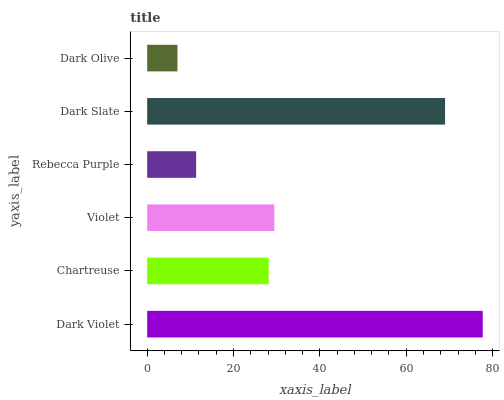Is Dark Olive the minimum?
Answer yes or no. Yes. Is Dark Violet the maximum?
Answer yes or no. Yes. Is Chartreuse the minimum?
Answer yes or no. No. Is Chartreuse the maximum?
Answer yes or no. No. Is Dark Violet greater than Chartreuse?
Answer yes or no. Yes. Is Chartreuse less than Dark Violet?
Answer yes or no. Yes. Is Chartreuse greater than Dark Violet?
Answer yes or no. No. Is Dark Violet less than Chartreuse?
Answer yes or no. No. Is Violet the high median?
Answer yes or no. Yes. Is Chartreuse the low median?
Answer yes or no. Yes. Is Chartreuse the high median?
Answer yes or no. No. Is Rebecca Purple the low median?
Answer yes or no. No. 